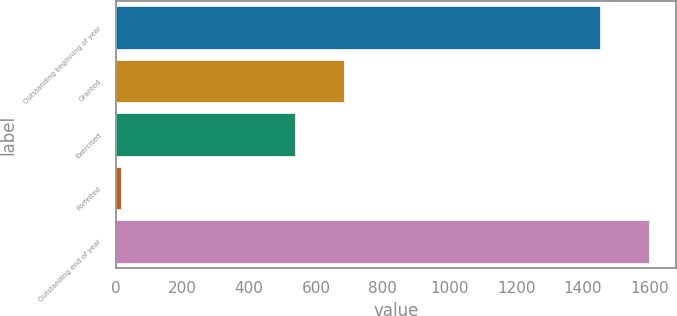Convert chart. <chart><loc_0><loc_0><loc_500><loc_500><bar_chart><fcel>Outstanding beginning of year<fcel>Granted<fcel>Exercised<fcel>Forfeited<fcel>Outstanding end of year<nl><fcel>1451<fcel>683<fcel>536<fcel>16<fcel>1598<nl></chart> 